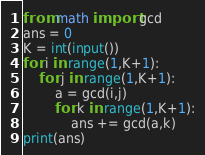<code> <loc_0><loc_0><loc_500><loc_500><_Python_>from math import gcd
ans = 0
K = int(input())
for i in range(1,K+1):
    for j in range(1,K+1):
        a = gcd(i,j)
        for k in range(1,K+1):
            ans += gcd(a,k)
print(ans)
</code> 